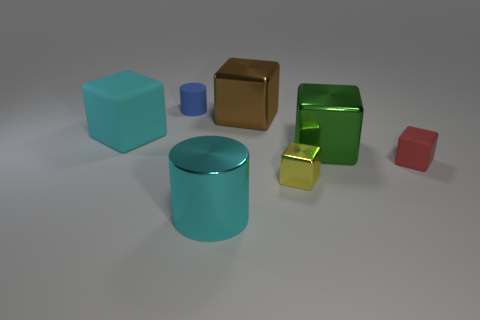The other rubber thing that is the same size as the brown object is what color?
Provide a short and direct response. Cyan. The rubber thing that is the same color as the large metallic cylinder is what shape?
Provide a succinct answer. Cube. Is there another small object that has the same shape as the small yellow metallic object?
Give a very brief answer. Yes. There is a yellow thing that is the same size as the red thing; what shape is it?
Your answer should be compact. Cube. How many things are either large blue objects or brown metallic cubes?
Offer a terse response. 1. Are any large cylinders visible?
Keep it short and to the point. Yes. Is the number of rubber objects less than the number of small brown objects?
Ensure brevity in your answer.  No. Are there any cyan metal objects of the same size as the blue object?
Provide a succinct answer. No. There is a big matte thing; does it have the same shape as the thing that is on the right side of the big green object?
Your response must be concise. Yes. What number of blocks are either cyan rubber objects or metal things?
Make the answer very short. 4. 